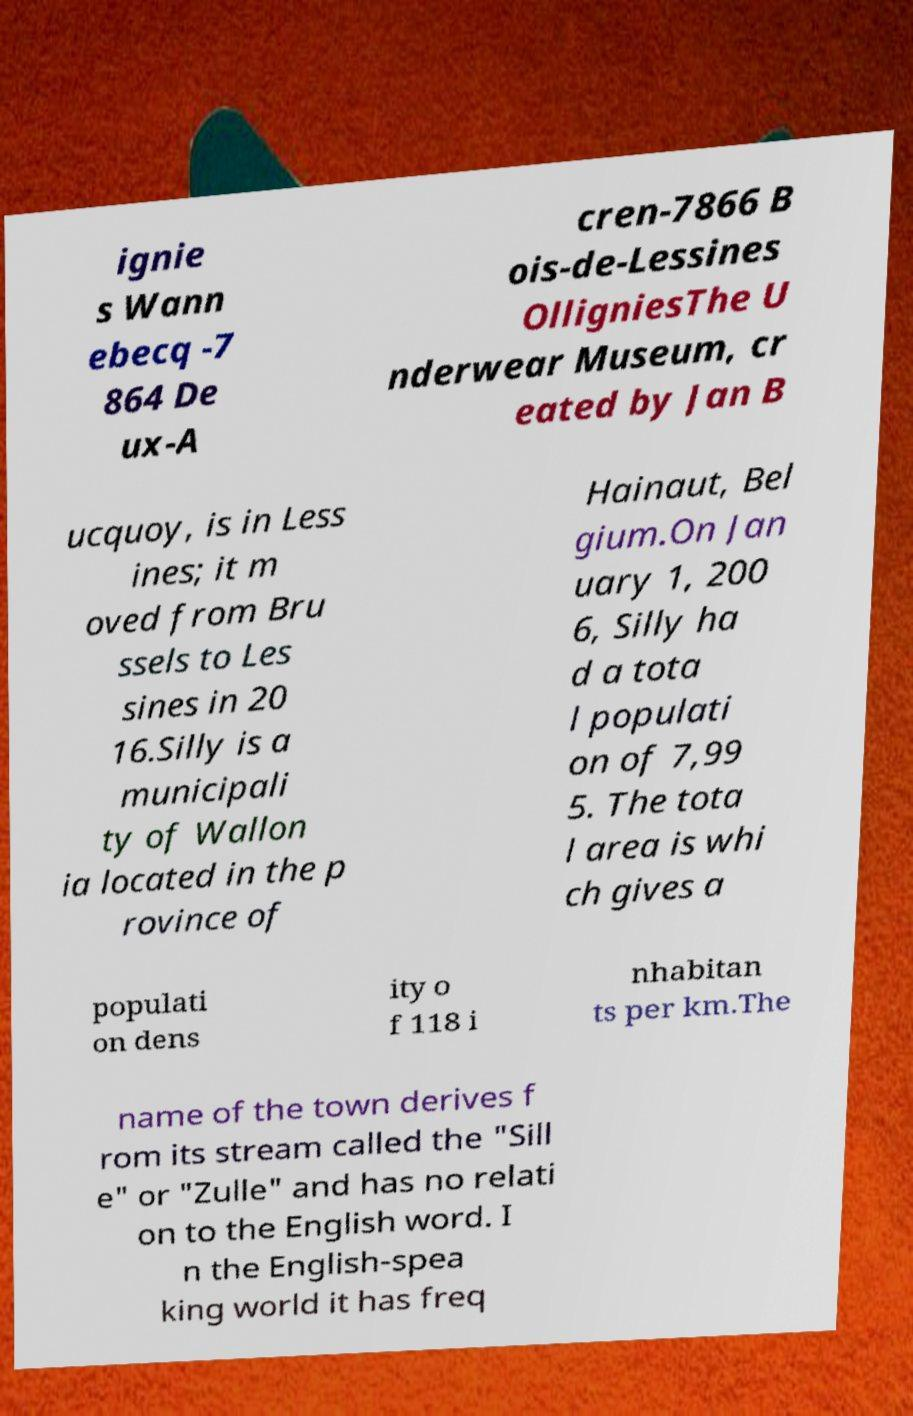Please read and relay the text visible in this image. What does it say? ignie s Wann ebecq -7 864 De ux-A cren-7866 B ois-de-Lessines OlligniesThe U nderwear Museum, cr eated by Jan B ucquoy, is in Less ines; it m oved from Bru ssels to Les sines in 20 16.Silly is a municipali ty of Wallon ia located in the p rovince of Hainaut, Bel gium.On Jan uary 1, 200 6, Silly ha d a tota l populati on of 7,99 5. The tota l area is whi ch gives a populati on dens ity o f 118 i nhabitan ts per km.The name of the town derives f rom its stream called the "Sill e" or "Zulle" and has no relati on to the English word. I n the English-spea king world it has freq 